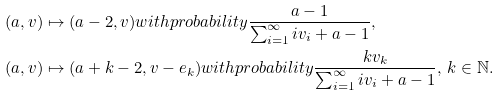<formula> <loc_0><loc_0><loc_500><loc_500>( a , { v } ) & \mapsto ( a - 2 , { v } ) w i t h p r o b a b i l i t y \frac { a - 1 } { \sum _ { i = 1 } ^ { \infty } i v _ { i } + a - 1 } , \\ ( a , { v } ) & \mapsto ( a + k - 2 , { v } - { e } _ { k } ) w i t h p r o b a b i l i t y \frac { k v _ { k } } { \sum _ { i = 1 } ^ { \infty } i v _ { i } + a - 1 } , \, k \in \mathbb { N } .</formula> 